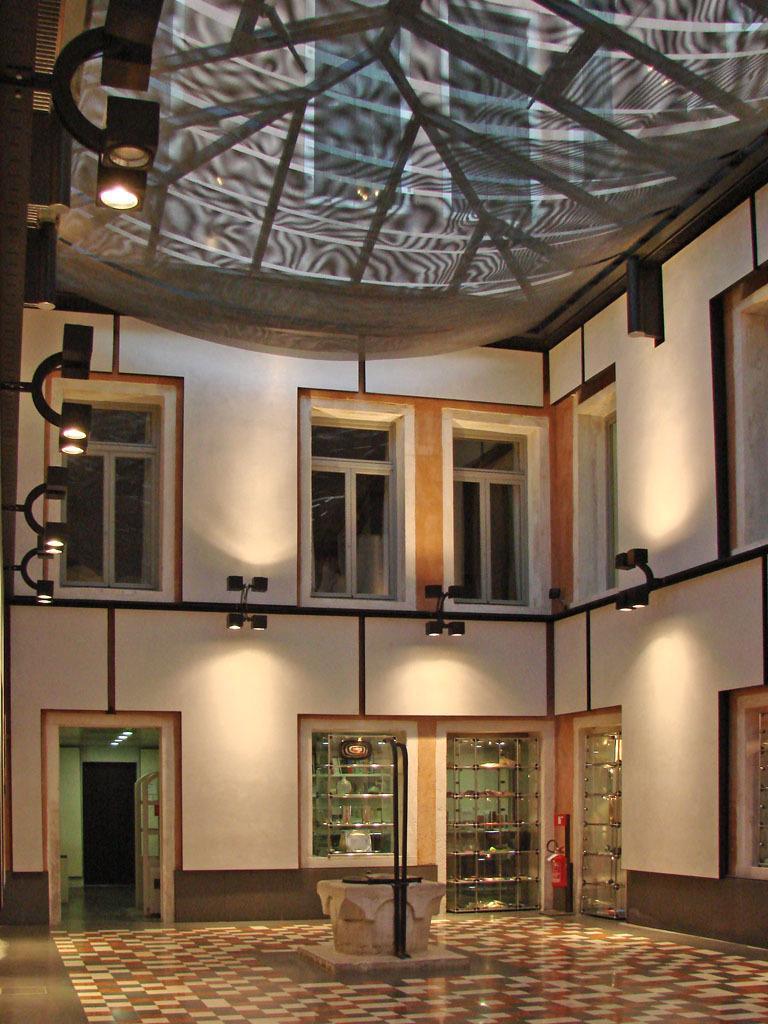Can you describe this image briefly? This image is taken inside a building. There are windows. There is a door. At the bottom of the image there is floor. At the top of the image there is cloth. There are lights. 